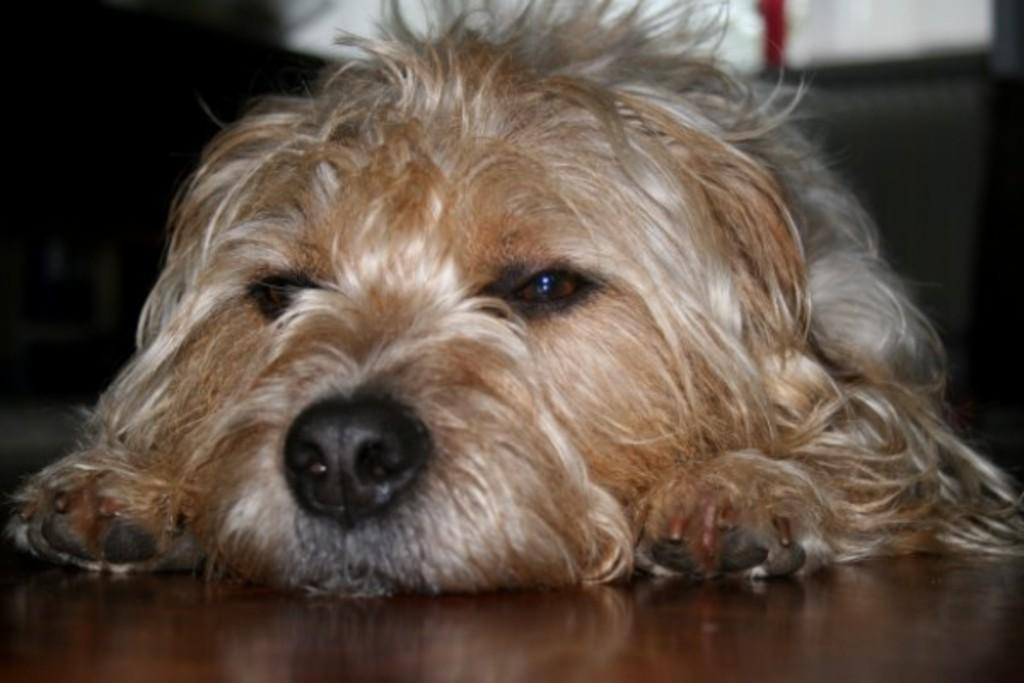What animal is present in the image? There is a dog in the image. What is the dog doing in the image? The dog is lying on the floor. Can you describe the background of the image? The background of the image is blurred. What type of vest is the dog wearing in the image? There is no vest present on the dog in the image. How many matches can be seen in the image? There are no matches visible in the image. 